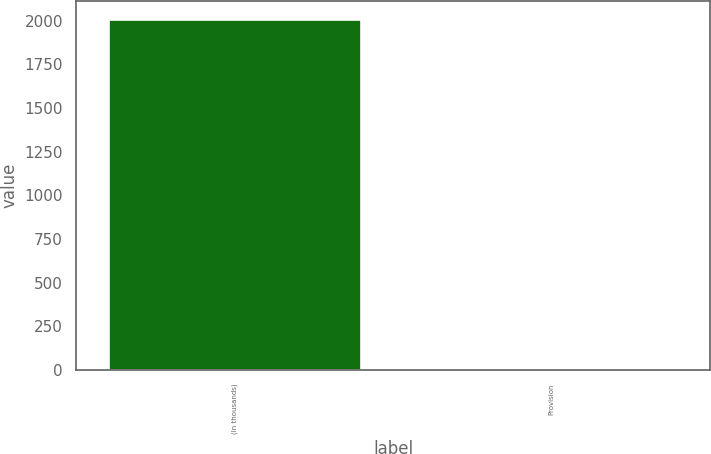Convert chart to OTSL. <chart><loc_0><loc_0><loc_500><loc_500><bar_chart><fcel>(In thousands)<fcel>Provision<nl><fcel>2009<fcel>5<nl></chart> 